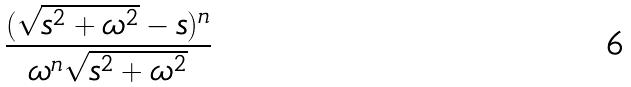Convert formula to latex. <formula><loc_0><loc_0><loc_500><loc_500>\frac { ( \sqrt { s ^ { 2 } + \omega ^ { 2 } } - s ) ^ { n } } { \omega ^ { n } \sqrt { s ^ { 2 } + \omega ^ { 2 } } }</formula> 